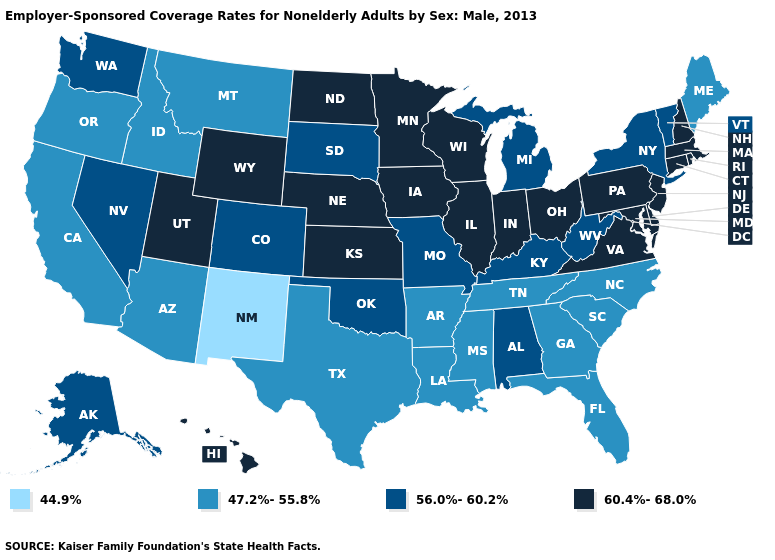Does South Dakota have the highest value in the MidWest?
Answer briefly. No. What is the value of Kansas?
Quick response, please. 60.4%-68.0%. Which states hav the highest value in the South?
Short answer required. Delaware, Maryland, Virginia. How many symbols are there in the legend?
Answer briefly. 4. Does New Mexico have the highest value in the USA?
Short answer required. No. What is the lowest value in states that border Arizona?
Keep it brief. 44.9%. What is the value of New York?
Write a very short answer. 56.0%-60.2%. Which states hav the highest value in the Northeast?
Write a very short answer. Connecticut, Massachusetts, New Hampshire, New Jersey, Pennsylvania, Rhode Island. Name the states that have a value in the range 47.2%-55.8%?
Quick response, please. Arizona, Arkansas, California, Florida, Georgia, Idaho, Louisiana, Maine, Mississippi, Montana, North Carolina, Oregon, South Carolina, Tennessee, Texas. What is the value of Rhode Island?
Write a very short answer. 60.4%-68.0%. Does Michigan have the lowest value in the MidWest?
Answer briefly. Yes. Which states have the lowest value in the Northeast?
Give a very brief answer. Maine. Does Michigan have a lower value than Oregon?
Write a very short answer. No. Among the states that border Tennessee , which have the highest value?
Short answer required. Virginia. Does Indiana have the highest value in the USA?
Quick response, please. Yes. 